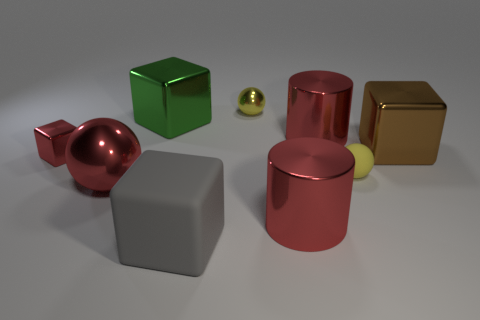Is the green object made of the same material as the large ball?
Ensure brevity in your answer.  Yes. What size is the green shiny thing that is the same shape as the gray matte thing?
Offer a terse response. Large. How many things are either spheres to the left of the green thing or large metallic cylinders behind the big brown metallic cube?
Offer a very short reply. 2. Is the number of gray matte cubes less than the number of red metal cylinders?
Provide a short and direct response. Yes. Do the green object and the shiny object that is to the left of the large metal ball have the same size?
Give a very brief answer. No. What number of shiny things are either big cylinders or big brown things?
Your answer should be compact. 3. Are there more large brown rubber cylinders than large brown metal cubes?
Keep it short and to the point. No. What is the size of the shiny ball that is the same color as the tiny matte object?
Your answer should be compact. Small. What is the shape of the yellow object on the right side of the object behind the green metallic block?
Your answer should be compact. Sphere. There is a large block that is right of the yellow sphere that is left of the tiny rubber sphere; is there a large ball behind it?
Provide a short and direct response. No. 